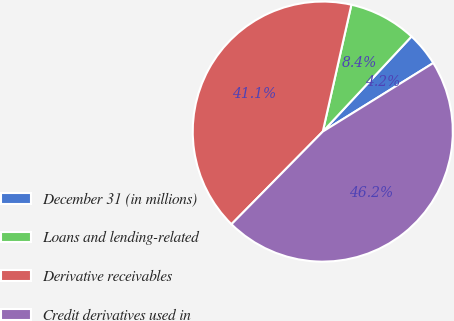Convert chart. <chart><loc_0><loc_0><loc_500><loc_500><pie_chart><fcel>December 31 (in millions)<fcel>Loans and lending-related<fcel>Derivative receivables<fcel>Credit derivatives used in<nl><fcel>4.21%<fcel>8.42%<fcel>41.15%<fcel>46.23%<nl></chart> 